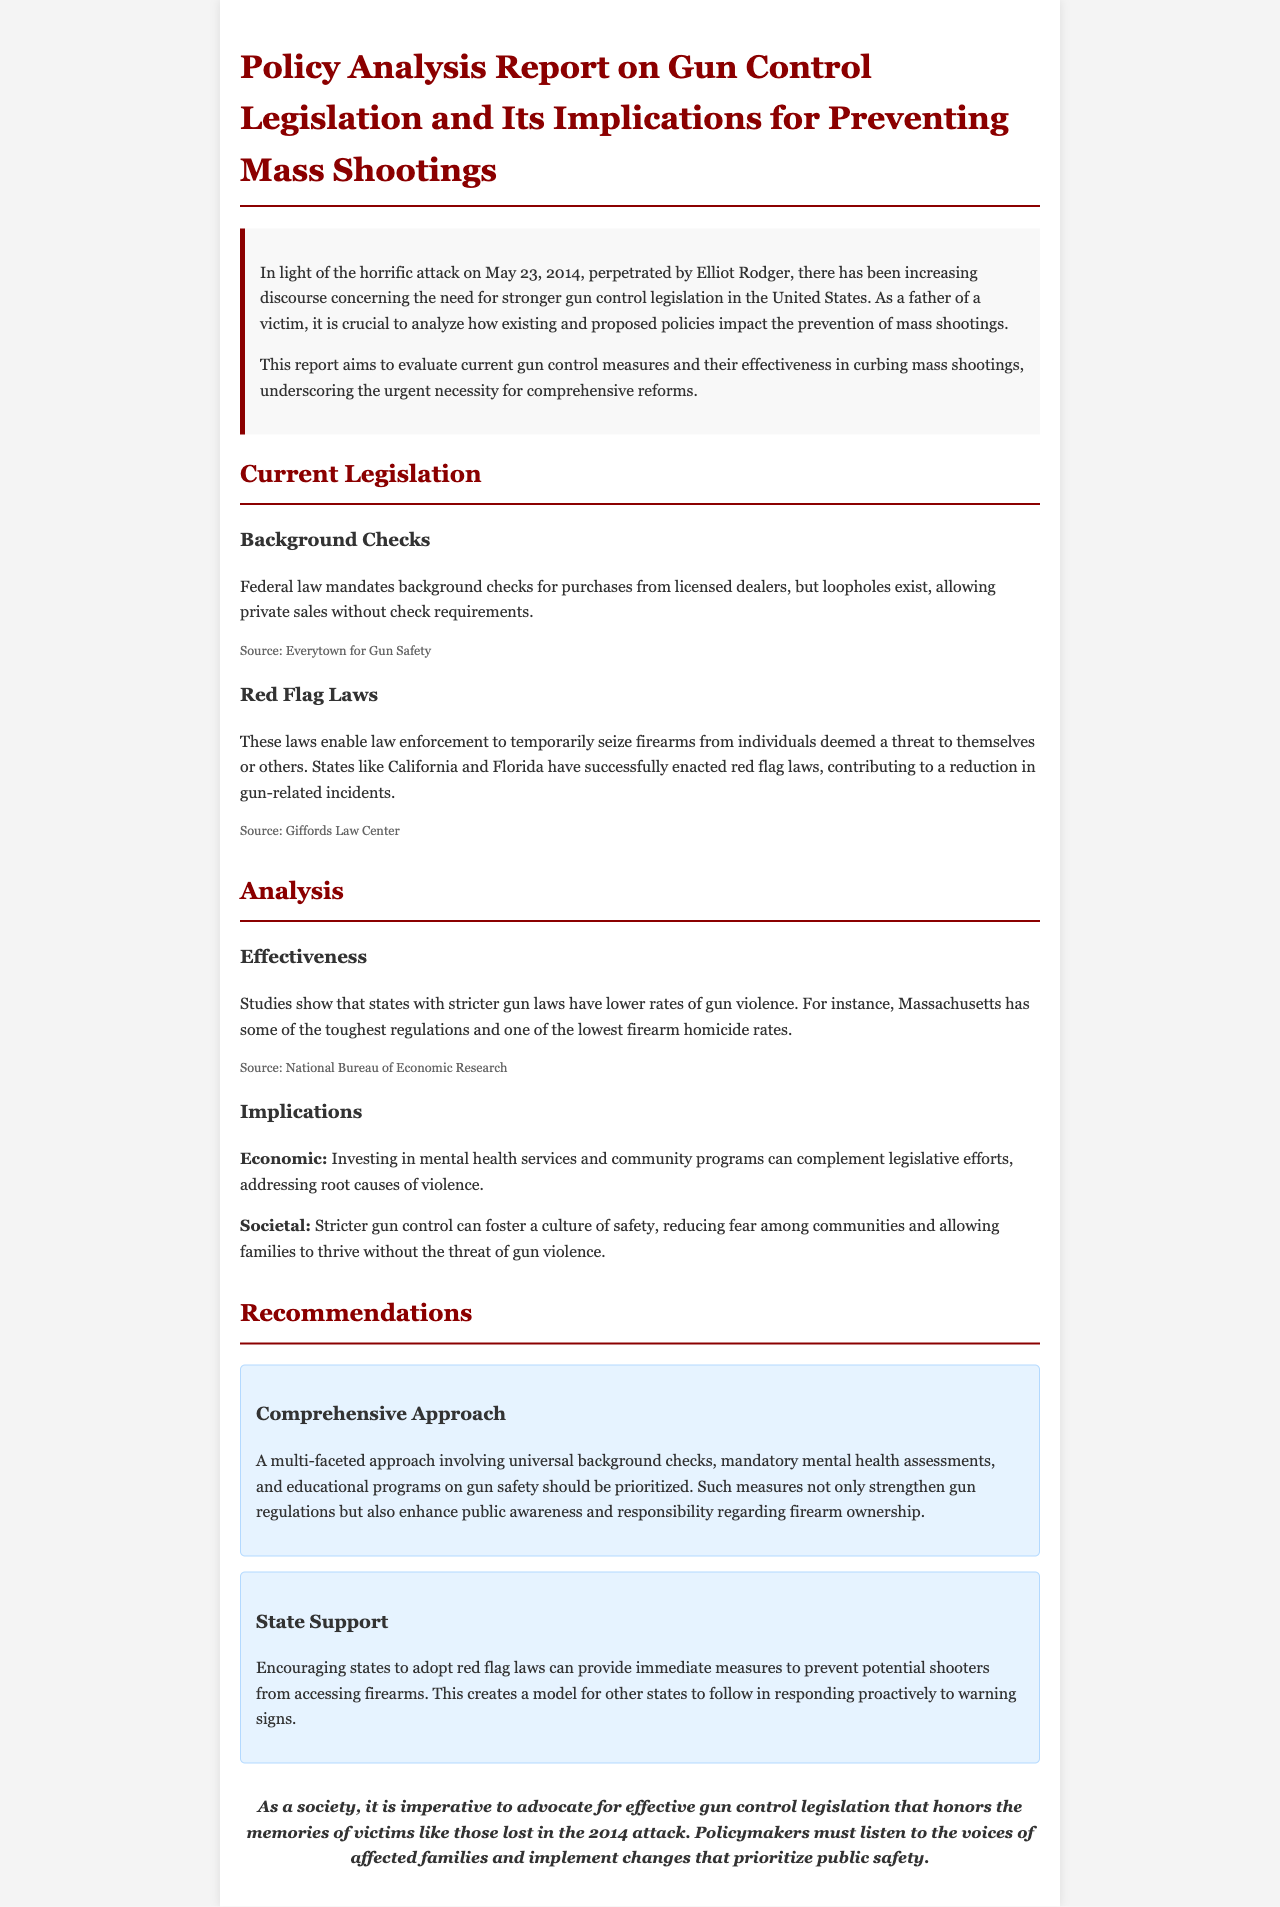what incident prompted the report? The report addresses the need for stronger gun control laws in response to the attack on May 23, 2014, by Elliot Rodger.
Answer: Elliot Rodger what does federal law mandate for licensed dealer purchases? The document states that federal law requires background checks for purchases from licensed dealers.
Answer: Background checks which states have successfully enacted red flag laws? The report mentions California and Florida as states that have enacted red flag laws.
Answer: California and Florida how do states with stricter gun laws compare to others in gun violence rates? The analysis indicates that states with stricter gun laws have lower rates of gun violence.
Answer: Lower rates what approach is recommended for gun control measures? The report recommends a multi-faceted approach including universal background checks and mental health assessments.
Answer: Multi-faceted approach what economic implication is noted in the report? Investing in mental health services and community programs is identified as an important economic implication.
Answer: Mental health services what is the purpose of red flag laws? Red flag laws are designed to enable law enforcement to temporarily seize firearms from individuals deemed a threat.
Answer: Seize firearms what is emphasized as a crucial action by policymakers? The report emphasizes that policymakers must listen to the voices of affected families.
Answer: Listen to affected families 